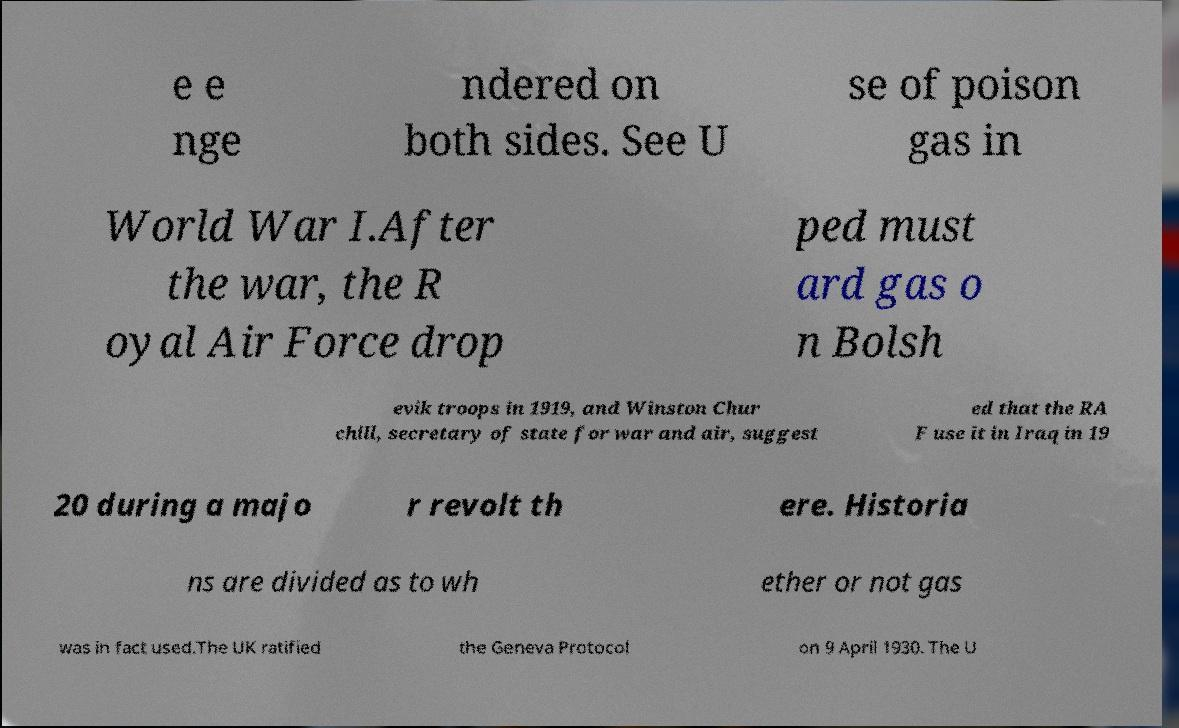What messages or text are displayed in this image? I need them in a readable, typed format. e e nge ndered on both sides. See U se of poison gas in World War I.After the war, the R oyal Air Force drop ped must ard gas o n Bolsh evik troops in 1919, and Winston Chur chill, secretary of state for war and air, suggest ed that the RA F use it in Iraq in 19 20 during a majo r revolt th ere. Historia ns are divided as to wh ether or not gas was in fact used.The UK ratified the Geneva Protocol on 9 April 1930. The U 